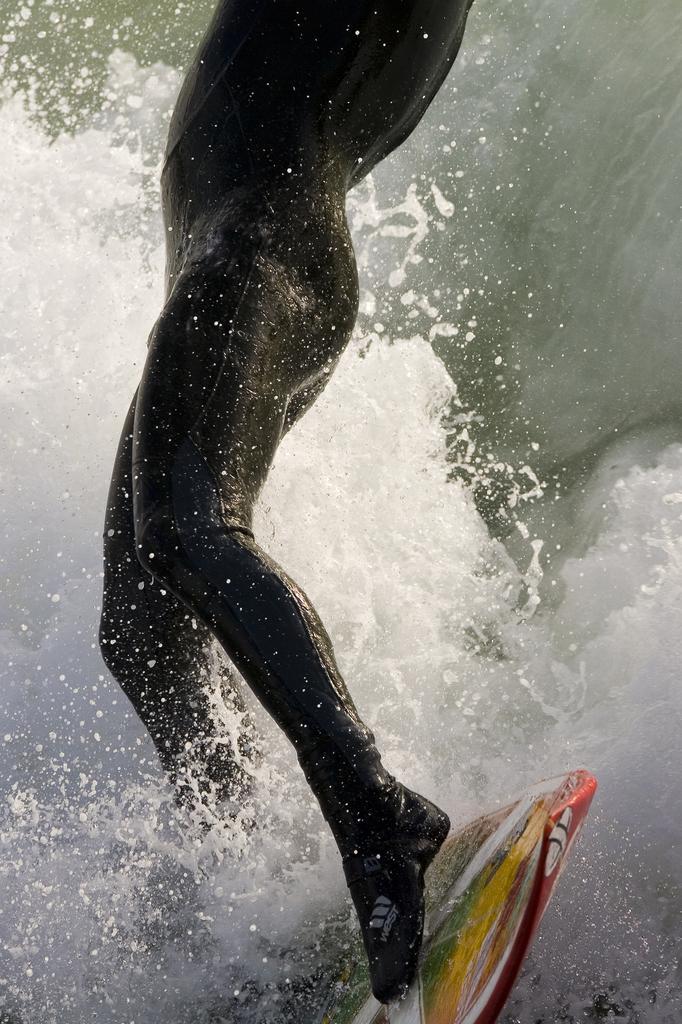Can you describe this image briefly? In this picture there is a person surfing in the water with surfboard. 